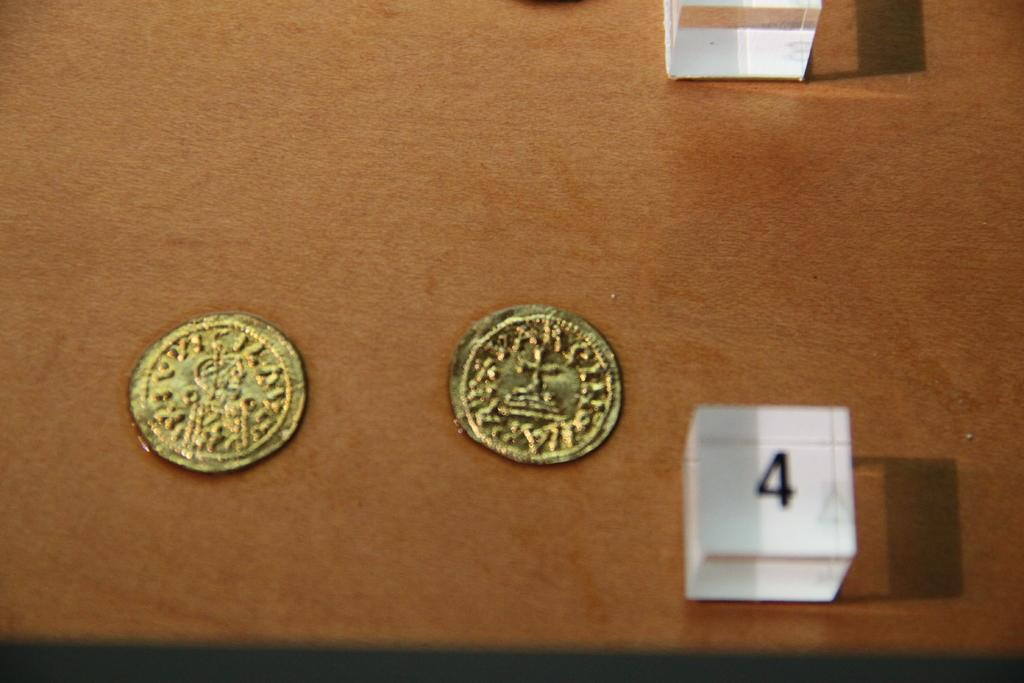<image>
Describe the image concisely. Two gold coins are on a table-top next to a sign with the number 4. 